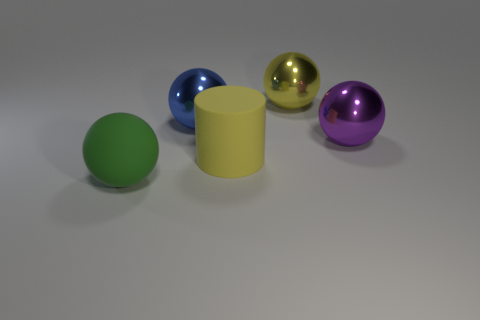Subtract all large yellow balls. How many balls are left? 3 Add 2 large purple shiny objects. How many large purple shiny objects are left? 3 Add 4 large matte cylinders. How many large matte cylinders exist? 5 Add 1 purple matte spheres. How many objects exist? 6 Subtract all blue balls. How many balls are left? 3 Subtract 0 yellow cubes. How many objects are left? 5 Subtract all cylinders. How many objects are left? 4 Subtract 3 spheres. How many spheres are left? 1 Subtract all brown cylinders. Subtract all purple balls. How many cylinders are left? 1 Subtract all green cylinders. How many green balls are left? 1 